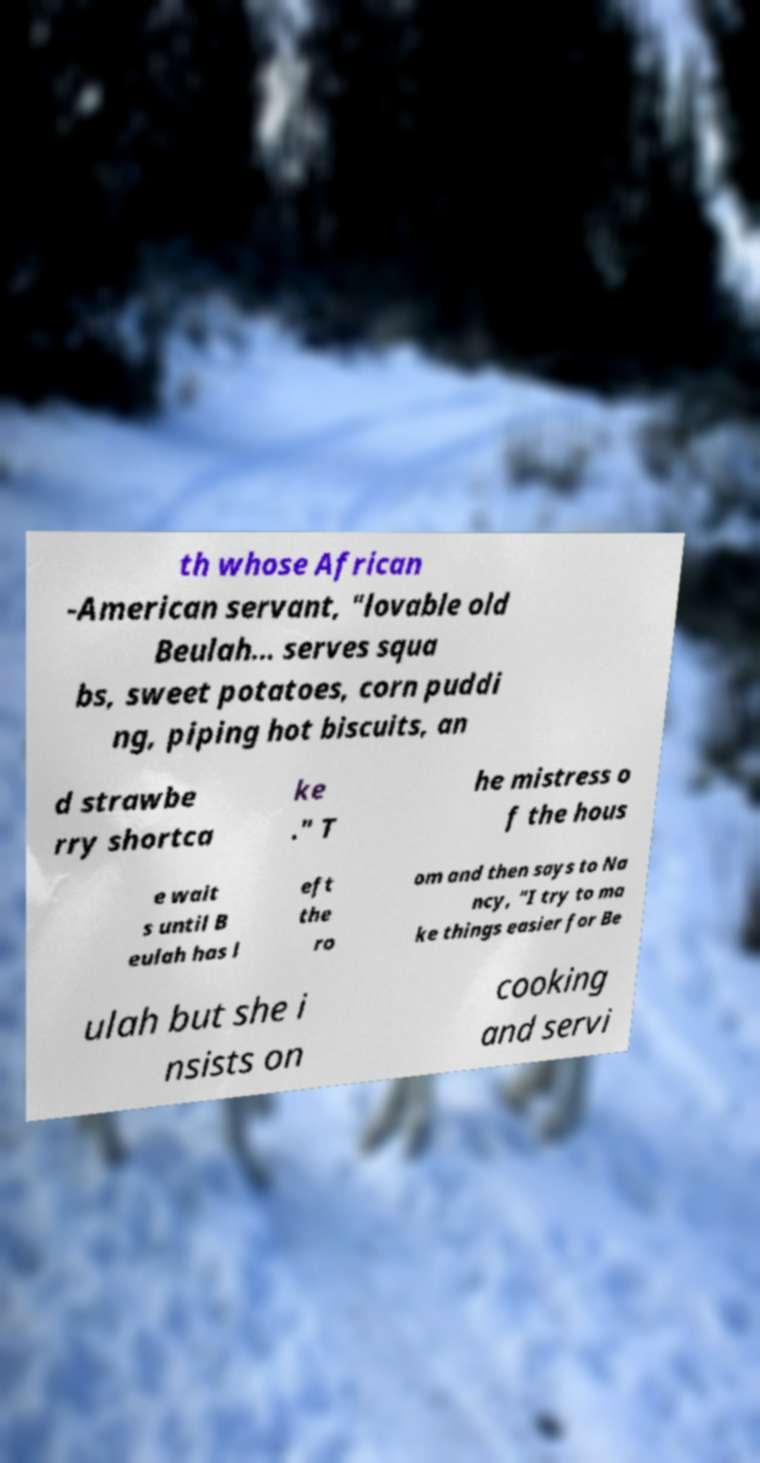Could you extract and type out the text from this image? th whose African -American servant, "lovable old Beulah… serves squa bs, sweet potatoes, corn puddi ng, piping hot biscuits, an d strawbe rry shortca ke ." T he mistress o f the hous e wait s until B eulah has l eft the ro om and then says to Na ncy, "I try to ma ke things easier for Be ulah but she i nsists on cooking and servi 